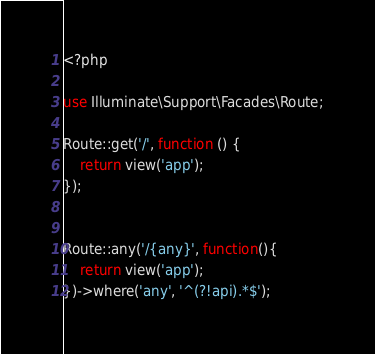<code> <loc_0><loc_0><loc_500><loc_500><_PHP_><?php

use Illuminate\Support\Facades\Route;

Route::get('/', function () {
    return view('app');
});


Route::any('/{any}', function(){
    return view('app');
})->where('any', '^(?!api).*$');</code> 